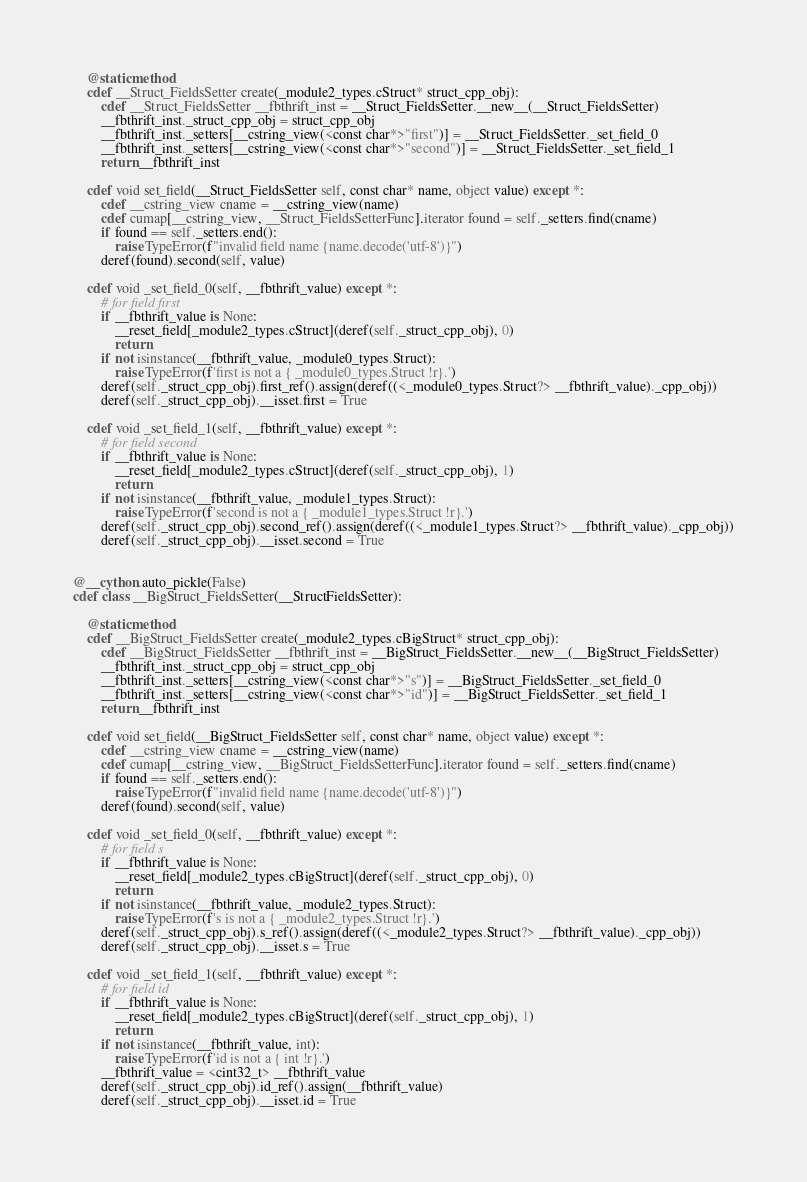<code> <loc_0><loc_0><loc_500><loc_500><_Cython_>    @staticmethod
    cdef __Struct_FieldsSetter create(_module2_types.cStruct* struct_cpp_obj):
        cdef __Struct_FieldsSetter __fbthrift_inst = __Struct_FieldsSetter.__new__(__Struct_FieldsSetter)
        __fbthrift_inst._struct_cpp_obj = struct_cpp_obj
        __fbthrift_inst._setters[__cstring_view(<const char*>"first")] = __Struct_FieldsSetter._set_field_0
        __fbthrift_inst._setters[__cstring_view(<const char*>"second")] = __Struct_FieldsSetter._set_field_1
        return __fbthrift_inst

    cdef void set_field(__Struct_FieldsSetter self, const char* name, object value) except *:
        cdef __cstring_view cname = __cstring_view(name)
        cdef cumap[__cstring_view, __Struct_FieldsSetterFunc].iterator found = self._setters.find(cname)
        if found == self._setters.end():
            raise TypeError(f"invalid field name {name.decode('utf-8')}")
        deref(found).second(self, value)

    cdef void _set_field_0(self, __fbthrift_value) except *:
        # for field first
        if __fbthrift_value is None:
            __reset_field[_module2_types.cStruct](deref(self._struct_cpp_obj), 0)
            return
        if not isinstance(__fbthrift_value, _module0_types.Struct):
            raise TypeError(f'first is not a { _module0_types.Struct !r}.')
        deref(self._struct_cpp_obj).first_ref().assign(deref((<_module0_types.Struct?> __fbthrift_value)._cpp_obj))
        deref(self._struct_cpp_obj).__isset.first = True

    cdef void _set_field_1(self, __fbthrift_value) except *:
        # for field second
        if __fbthrift_value is None:
            __reset_field[_module2_types.cStruct](deref(self._struct_cpp_obj), 1)
            return
        if not isinstance(__fbthrift_value, _module1_types.Struct):
            raise TypeError(f'second is not a { _module1_types.Struct !r}.')
        deref(self._struct_cpp_obj).second_ref().assign(deref((<_module1_types.Struct?> __fbthrift_value)._cpp_obj))
        deref(self._struct_cpp_obj).__isset.second = True


@__cython.auto_pickle(False)
cdef class __BigStruct_FieldsSetter(__StructFieldsSetter):

    @staticmethod
    cdef __BigStruct_FieldsSetter create(_module2_types.cBigStruct* struct_cpp_obj):
        cdef __BigStruct_FieldsSetter __fbthrift_inst = __BigStruct_FieldsSetter.__new__(__BigStruct_FieldsSetter)
        __fbthrift_inst._struct_cpp_obj = struct_cpp_obj
        __fbthrift_inst._setters[__cstring_view(<const char*>"s")] = __BigStruct_FieldsSetter._set_field_0
        __fbthrift_inst._setters[__cstring_view(<const char*>"id")] = __BigStruct_FieldsSetter._set_field_1
        return __fbthrift_inst

    cdef void set_field(__BigStruct_FieldsSetter self, const char* name, object value) except *:
        cdef __cstring_view cname = __cstring_view(name)
        cdef cumap[__cstring_view, __BigStruct_FieldsSetterFunc].iterator found = self._setters.find(cname)
        if found == self._setters.end():
            raise TypeError(f"invalid field name {name.decode('utf-8')}")
        deref(found).second(self, value)

    cdef void _set_field_0(self, __fbthrift_value) except *:
        # for field s
        if __fbthrift_value is None:
            __reset_field[_module2_types.cBigStruct](deref(self._struct_cpp_obj), 0)
            return
        if not isinstance(__fbthrift_value, _module2_types.Struct):
            raise TypeError(f's is not a { _module2_types.Struct !r}.')
        deref(self._struct_cpp_obj).s_ref().assign(deref((<_module2_types.Struct?> __fbthrift_value)._cpp_obj))
        deref(self._struct_cpp_obj).__isset.s = True

    cdef void _set_field_1(self, __fbthrift_value) except *:
        # for field id
        if __fbthrift_value is None:
            __reset_field[_module2_types.cBigStruct](deref(self._struct_cpp_obj), 1)
            return
        if not isinstance(__fbthrift_value, int):
            raise TypeError(f'id is not a { int !r}.')
        __fbthrift_value = <cint32_t> __fbthrift_value
        deref(self._struct_cpp_obj).id_ref().assign(__fbthrift_value)
        deref(self._struct_cpp_obj).__isset.id = True

</code> 